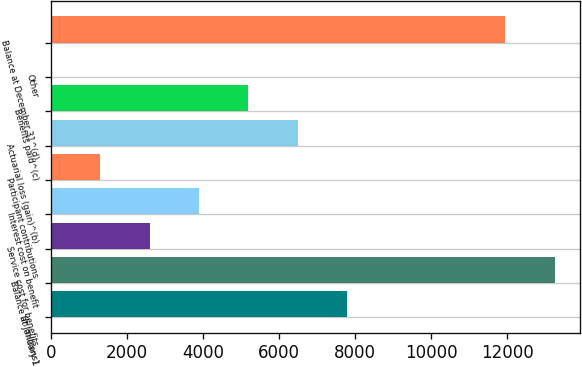Convert chart. <chart><loc_0><loc_0><loc_500><loc_500><bar_chart><fcel>(In millions)<fcel>Balance at January 1<fcel>Service cost for benefits<fcel>Interest cost on benefit<fcel>Participant contributions<fcel>Actuarial loss (gain)^(b)<fcel>Benefits paid^(c)<fcel>Other<fcel>Balance at December 31^(d)<nl><fcel>7790.2<fcel>13247.2<fcel>2597.4<fcel>3895.6<fcel>1299.2<fcel>6492<fcel>5193.8<fcel>1<fcel>11949<nl></chart> 